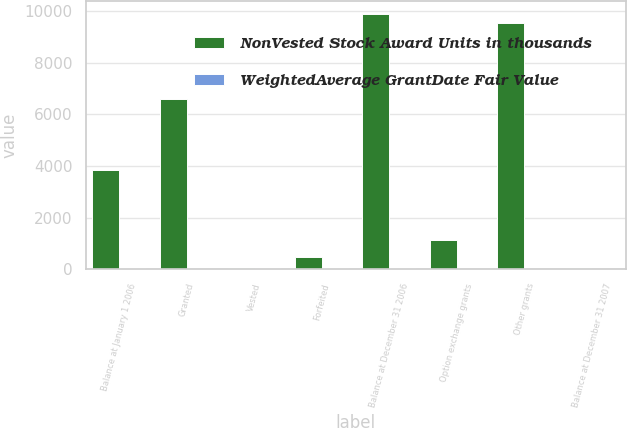<chart> <loc_0><loc_0><loc_500><loc_500><stacked_bar_chart><ecel><fcel>Balance at January 1 2006<fcel>Granted<fcel>Vested<fcel>Forfeited<fcel>Balance at December 31 2006<fcel>Option exchange grants<fcel>Other grants<fcel>Balance at December 31 2007<nl><fcel>NonVested Stock Award Units in thousands<fcel>3834<fcel>6580<fcel>52<fcel>487<fcel>9875<fcel>1115<fcel>9545<fcel>32<nl><fcel>WeightedAverage GrantDate Fair Value<fcel>30<fcel>23<fcel>32<fcel>28<fcel>26<fcel>16<fcel>17<fcel>20<nl></chart> 